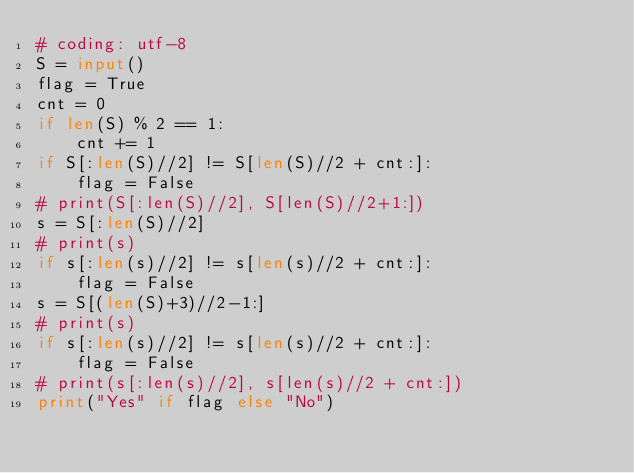Convert code to text. <code><loc_0><loc_0><loc_500><loc_500><_Python_># coding: utf-8
S = input()
flag = True
cnt = 0
if len(S) % 2 == 1:
    cnt += 1
if S[:len(S)//2] != S[len(S)//2 + cnt:]:
    flag = False
# print(S[:len(S)//2], S[len(S)//2+1:])
s = S[:len(S)//2]
# print(s)
if s[:len(s)//2] != s[len(s)//2 + cnt:]:
    flag = False
s = S[(len(S)+3)//2-1:]
# print(s)
if s[:len(s)//2] != s[len(s)//2 + cnt:]:
    flag = False
# print(s[:len(s)//2], s[len(s)//2 + cnt:])
print("Yes" if flag else "No")</code> 